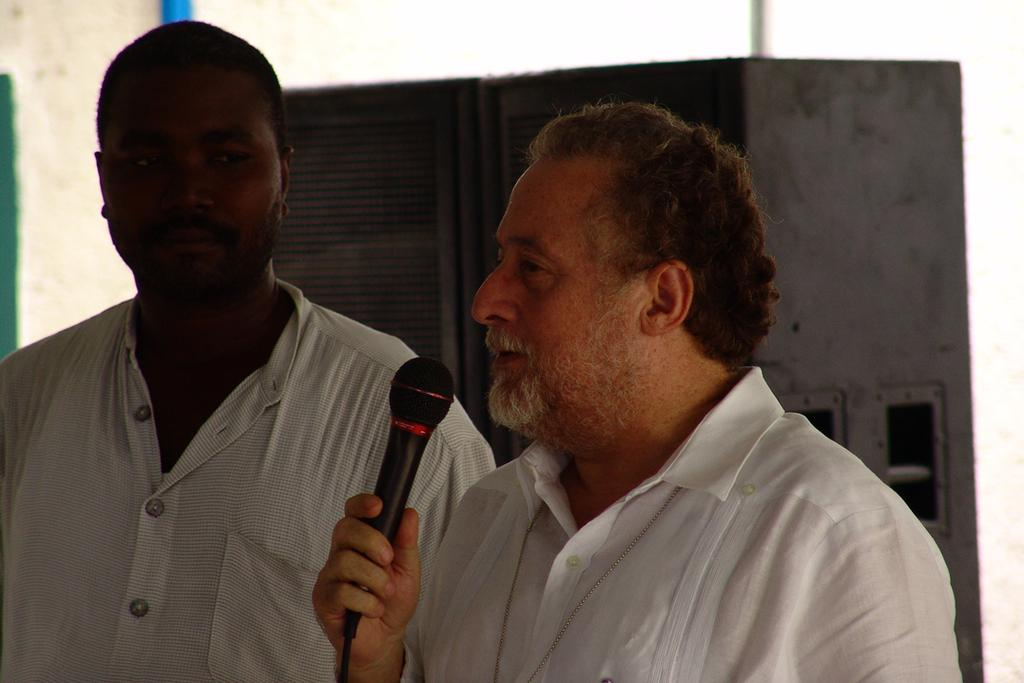How many people are in the image? There are two persons in the image. What is the person on the right side holding? The person on the right side is holding a microphone. What are the shirts of both persons in the image? Both persons are wearing white shirts. What can be seen in the background of the image? There is a wall in the background of the image. What type of fowl can be seen in the image? There is no fowl present in the image. What experience do the persons in the image have in common? The provided facts do not give any information about the experience or background of the persons in the image. 